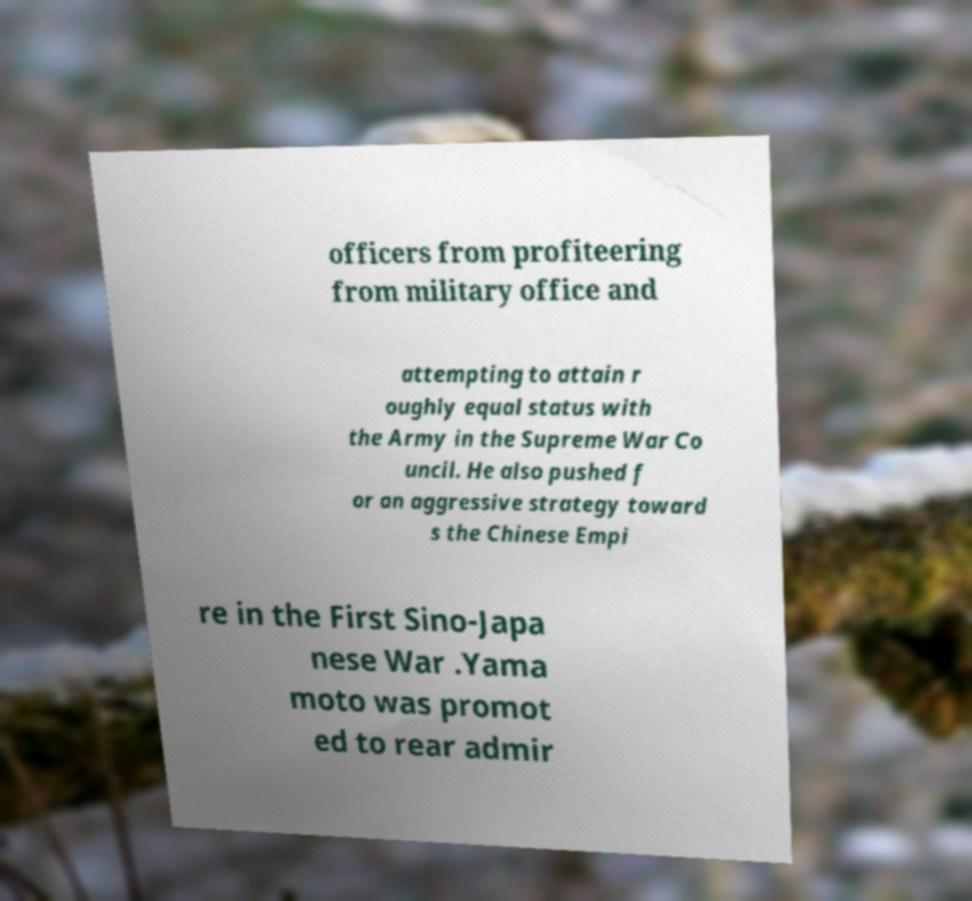Can you accurately transcribe the text from the provided image for me? officers from profiteering from military office and attempting to attain r oughly equal status with the Army in the Supreme War Co uncil. He also pushed f or an aggressive strategy toward s the Chinese Empi re in the First Sino-Japa nese War .Yama moto was promot ed to rear admir 